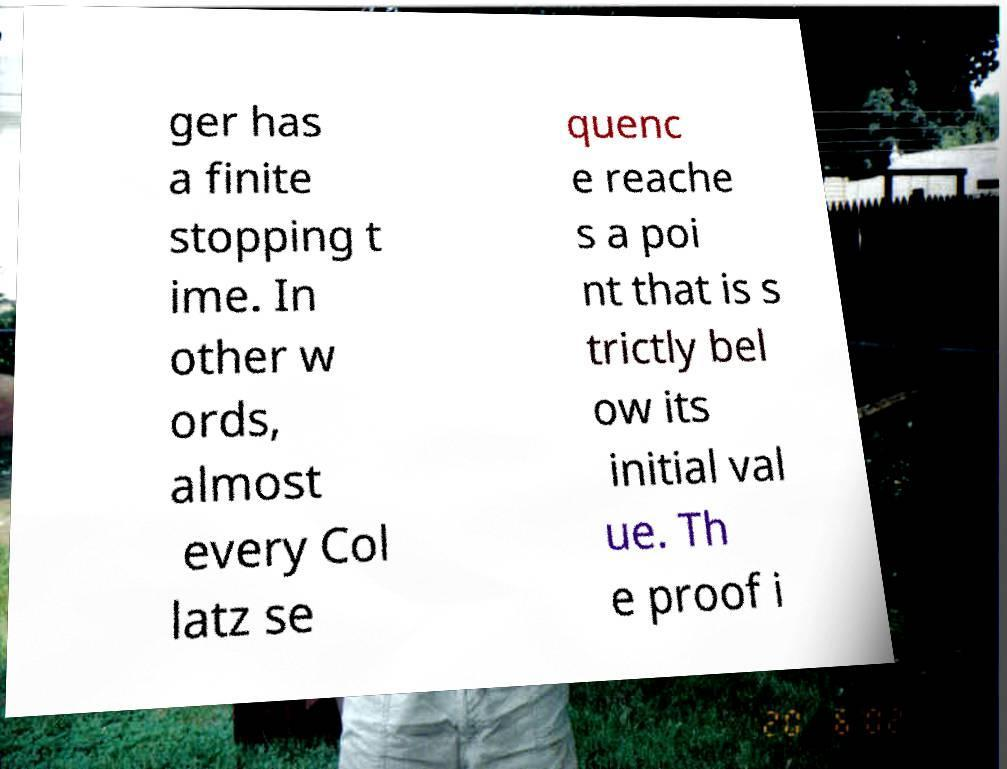Please identify and transcribe the text found in this image. ger has a finite stopping t ime. In other w ords, almost every Col latz se quenc e reache s a poi nt that is s trictly bel ow its initial val ue. Th e proof i 